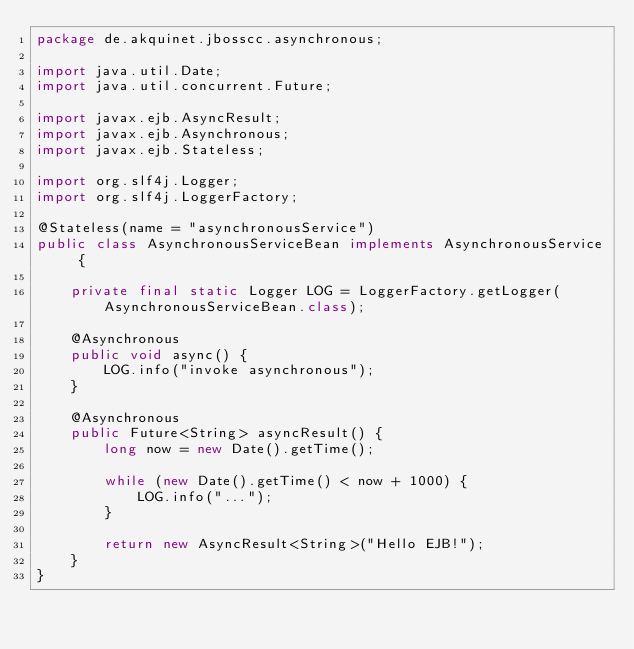<code> <loc_0><loc_0><loc_500><loc_500><_Java_>package de.akquinet.jbosscc.asynchronous;

import java.util.Date;
import java.util.concurrent.Future;

import javax.ejb.AsyncResult;
import javax.ejb.Asynchronous;
import javax.ejb.Stateless;

import org.slf4j.Logger;
import org.slf4j.LoggerFactory;

@Stateless(name = "asynchronousService")
public class AsynchronousServiceBean implements AsynchronousService {

    private final static Logger LOG = LoggerFactory.getLogger(AsynchronousServiceBean.class);

    @Asynchronous
    public void async() {
        LOG.info("invoke asynchronous");
    }

    @Asynchronous
    public Future<String> asyncResult() {
        long now = new Date().getTime();

        while (new Date().getTime() < now + 1000) {
            LOG.info("...");
        }

        return new AsyncResult<String>("Hello EJB!");
    }
}
</code> 